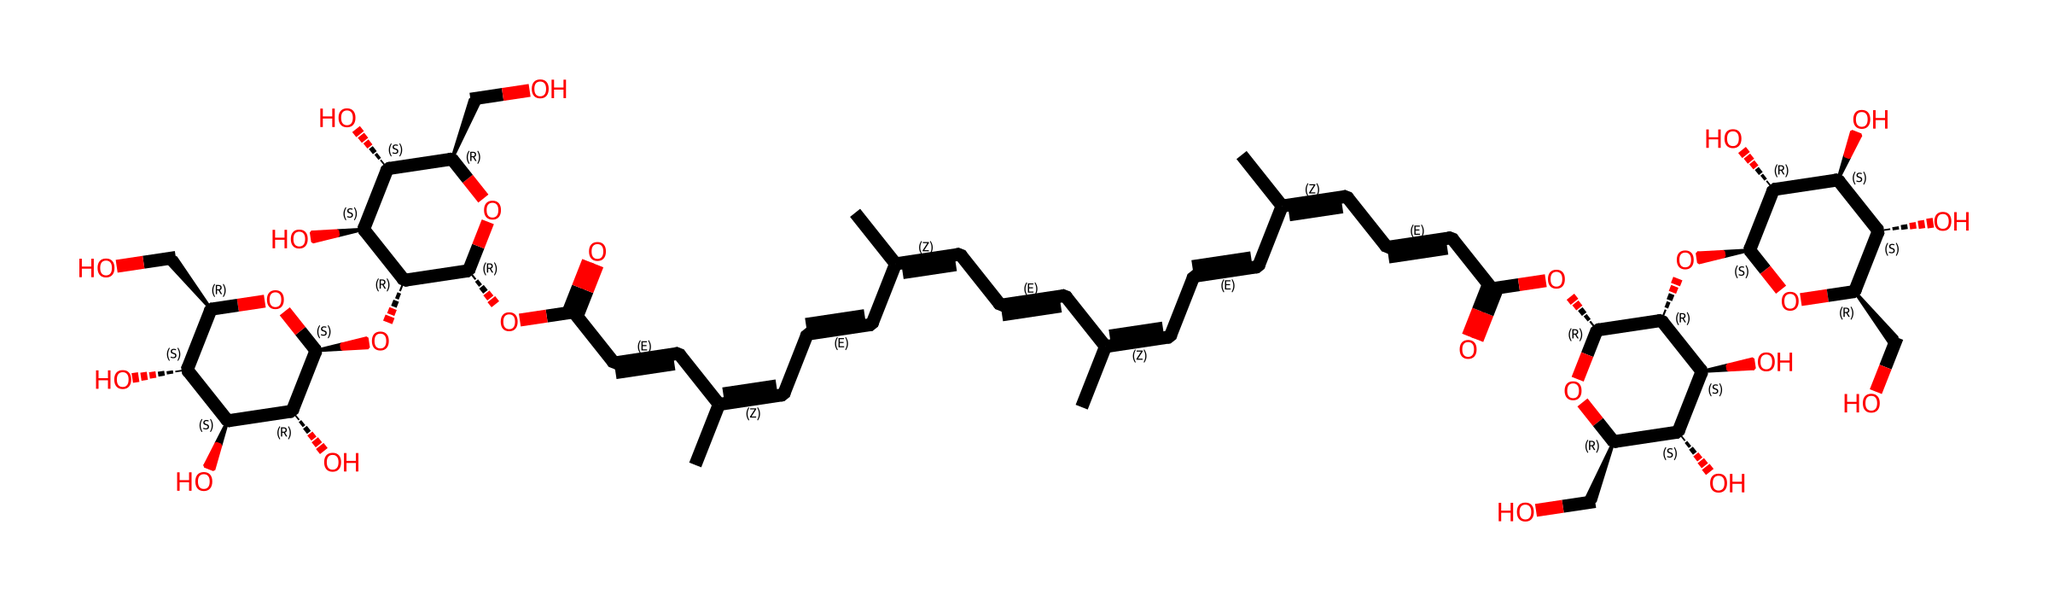What is the primary functional group present in saffron? The structure contains carboxylic acid groups (-COOH) indicated by the carbon atoms double-bonded to oxygen atoms and single-bonded to a hydroxyl group. This is typical for biochemicals involving acids.
Answer: carboxylic acid How many hydroxyl groups are present in the compound? By examining the structure, we can count the number of -OH (hydroxyl) groups. There are 6 hydroxyl groups visible in the structure, characterized by the -OH groups attached to carbon atoms.
Answer: 6 What is the molecular formula derived from the SMILES representation? First, identify all the atoms present in the structure by decoding the SMILES. For this chemical, after analyzing the atom types and counting, the molecular formula is confirmed as C28H34O18.
Answer: C28H34O18 Are there any double bonds present in the chemical structure? The SMILES representation indicates multiple occurrences of "/C=C/", denoting double bonds between carbon atoms. This signifies unsaturation in the hydrocarbon part of the molecule.
Answer: Yes What type of biochemical classification does saffron fit into? Given the functional groups present and the molecular complexity, saffron can be classified as a flavonoid due to the presence of phenolic components and multiple hydroxyl groups.
Answer: flavonoid What is the significance of the stereochemistry indicated in the SMILES? The presence of "@", which signifies stereocenters in the SMILES, indicates that the molecule has chiral centers, meaning it can exist in multiple stereoisomer forms. This often affects the biological activity and properties of the compound.
Answer: chiral centers How many carbon atoms are present in the chemical structure? Counting the carbon atoms from the SMILES, we see multiple instances of carbon represented throughout, totaling to 28 carbon atoms in the overall structure.
Answer: 28 